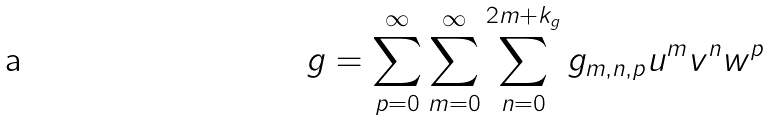Convert formula to latex. <formula><loc_0><loc_0><loc_500><loc_500>g = \sum _ { p = 0 } ^ { \infty } \sum _ { m = 0 } ^ { \infty } \sum _ { n = 0 } ^ { 2 m + k _ { g } } g _ { m , n , p } u ^ { m } v ^ { n } w ^ { p }</formula> 